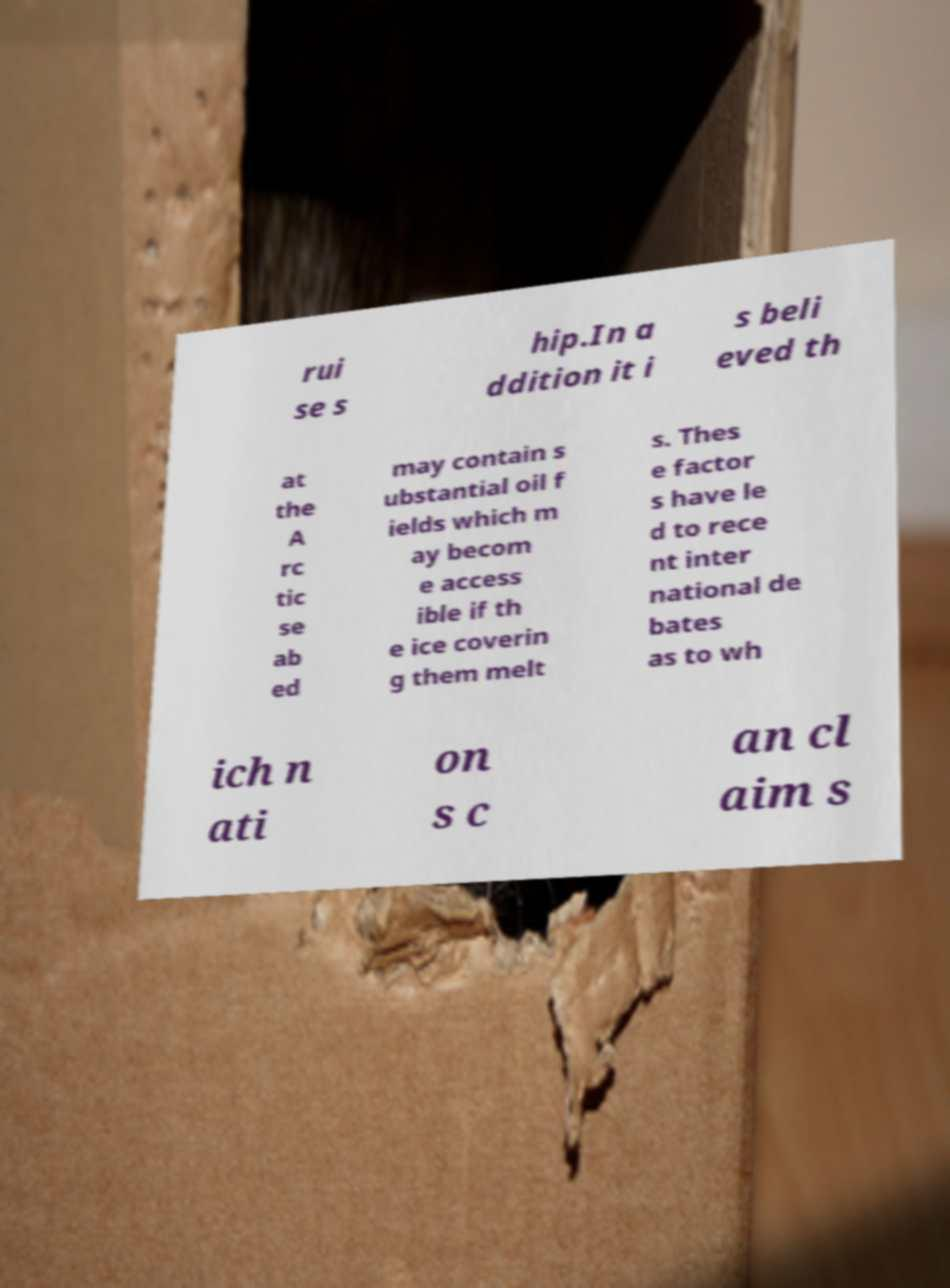Could you extract and type out the text from this image? rui se s hip.In a ddition it i s beli eved th at the A rc tic se ab ed may contain s ubstantial oil f ields which m ay becom e access ible if th e ice coverin g them melt s. Thes e factor s have le d to rece nt inter national de bates as to wh ich n ati on s c an cl aim s 